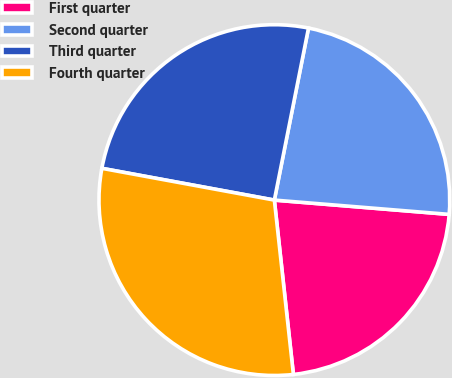<chart> <loc_0><loc_0><loc_500><loc_500><pie_chart><fcel>First quarter<fcel>Second quarter<fcel>Third quarter<fcel>Fourth quarter<nl><fcel>21.97%<fcel>23.18%<fcel>25.22%<fcel>29.63%<nl></chart> 